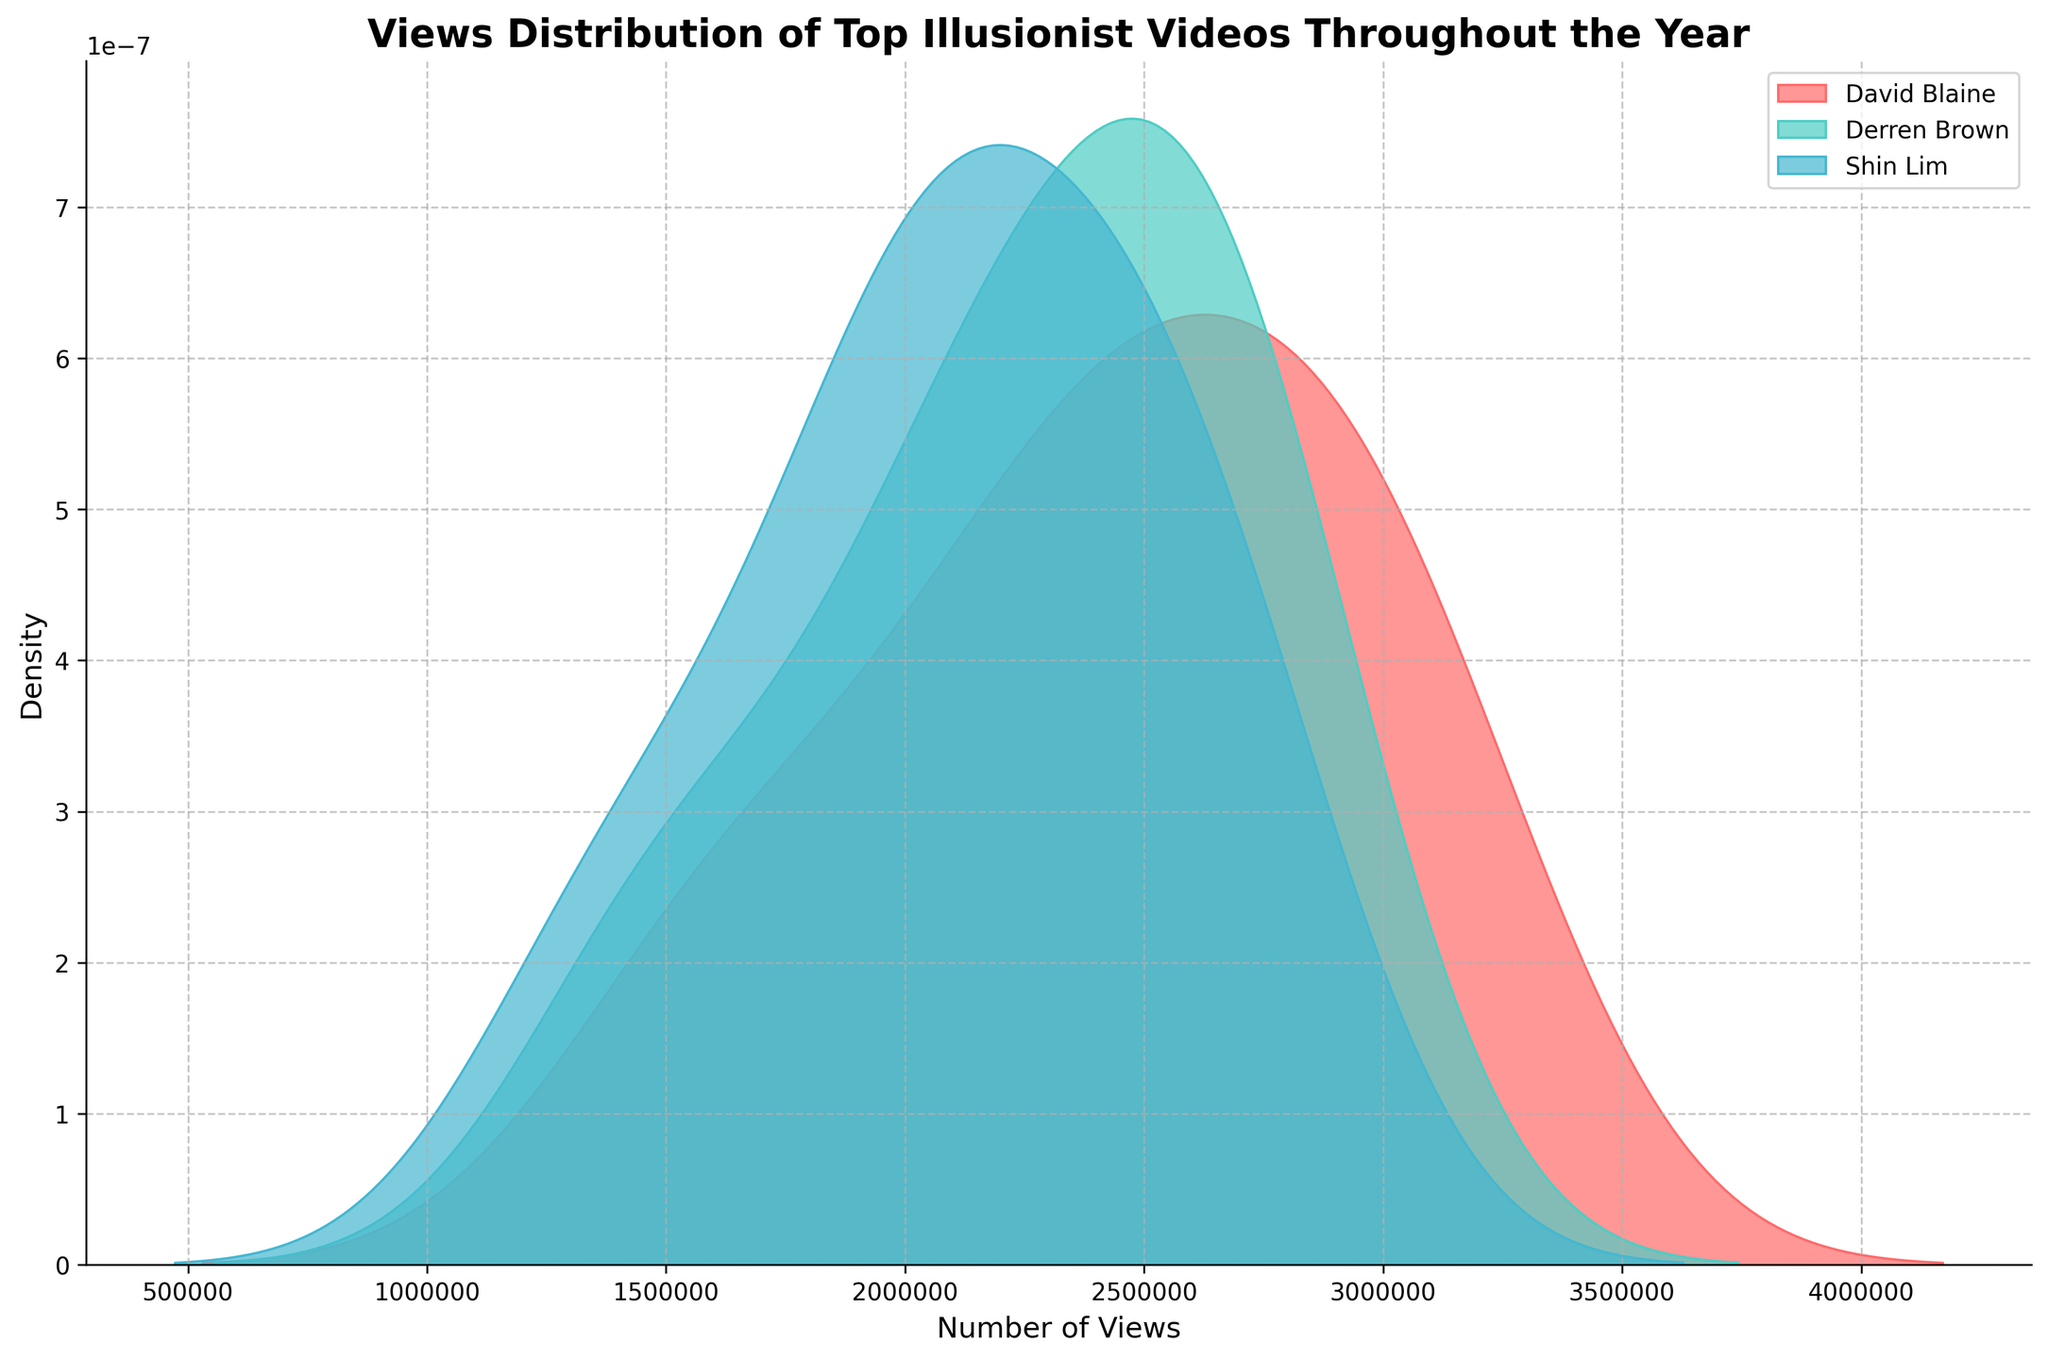What's the title of the figure? The title is displayed at the top of the figure in a bold, larger font size. It provides an overview of what the data in the figure represents.
Answer: Views Distribution of Top Illusionist Videos Throughout the Year Which illusionist's videos show the highest density of views? Looking at the figure, you can observe which curve has the highest peaks. The one with the tallest and most prominent density distribution indicates the highest density of views.
Answer: David Blaine How many unique illusionists are represented in the figure? Count the number of different labels in the legend of the figure. Each label represents a unique illusionist.
Answer: 3 What color represents Derren Brown? The legend of the figure assigns specific colors to each illusionist. Identify the color associated with Derren Brown in the legend.
Answer: Teal (#4ECDC4) Which illusionist has the most evenly distributed views throughout the year? Examine the smoothness and spread of the density curves. The illusionist with the curve that is the flattest and most evenly spread out without sharp peaks indicates an even distribution of views.
Answer: Derren Brown During which range do David Blaine's videos have the highest density of views? Look at the peak of David Blaine's curve and note the range on the x-axis where this peak occurs.
Answer: Between 2,500,000 and 3,000,000 views What is the approximate density value at the peak of Shin Lim's distribution? Identify the highest point on Shin Lim’s density curve and note its position on the y-axis.
Answer: Approximately 2.5 x 10^-7 Compare the density distributions of views in October for all three illusionists. Which one has the highest views in that month? Examine the density distributions around the region of October data points for each illusionist. The illusionist with a taller or higher density peak here would have more views in October.
Answer: David Blaine Which illusionist exhibits the highest variability in monthly video views? The illusionist with the widest spread (the longest range of the x-axis) in the density curve suggests a higher variability in views.
Answer: Shin Lim What can we infer about the views of David Blaine's videos compared to others over the year? David Blaine's density curve is the tallest and most prominent across the x-axis, which suggests his videos consistently obtain higher views throughout the year compared to others.
Answer: David Blaine's videos generally have higher views 